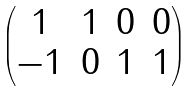<formula> <loc_0><loc_0><loc_500><loc_500>\begin{pmatrix} 1 & 1 & 0 & 0 \\ - 1 & 0 & 1 & 1 \\ \end{pmatrix}</formula> 